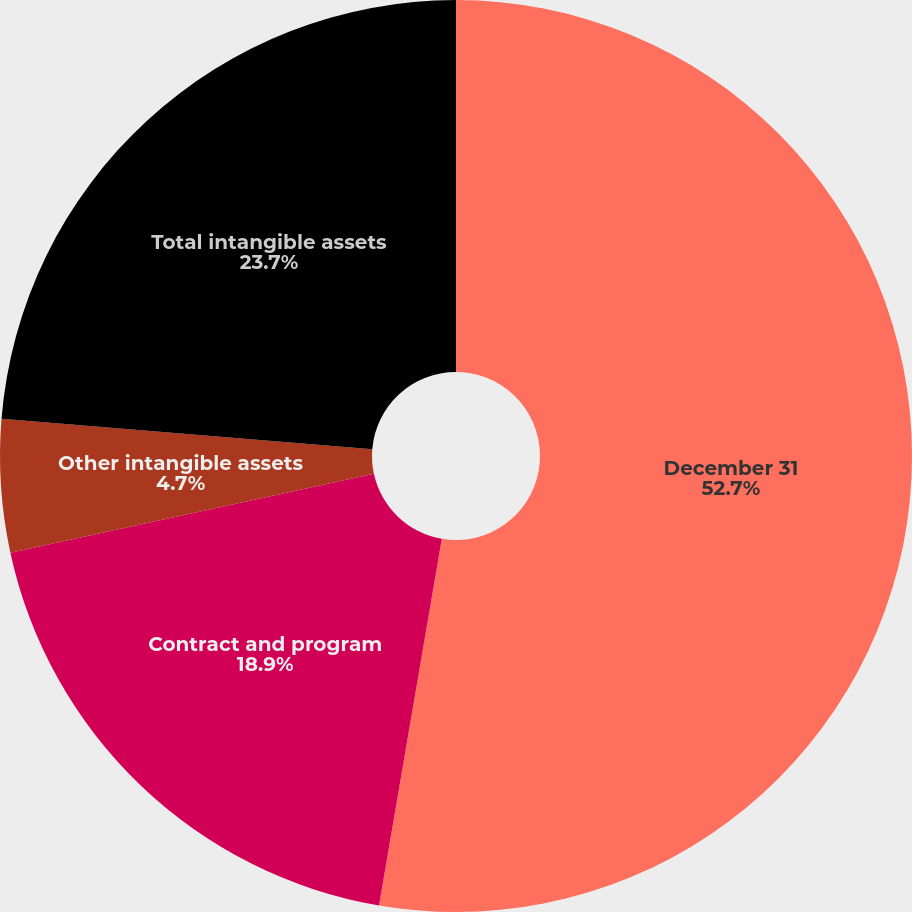<chart> <loc_0><loc_0><loc_500><loc_500><pie_chart><fcel>December 31<fcel>Contract and program<fcel>Other intangible assets<fcel>Total intangible assets<nl><fcel>52.7%<fcel>18.9%<fcel>4.7%<fcel>23.7%<nl></chart> 